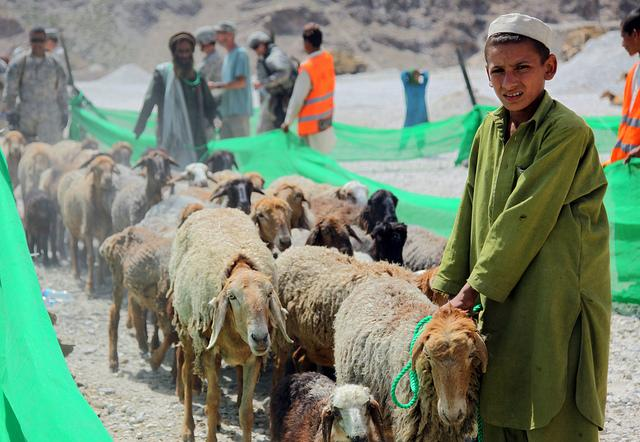Why are the men's vests orange in color? construction 